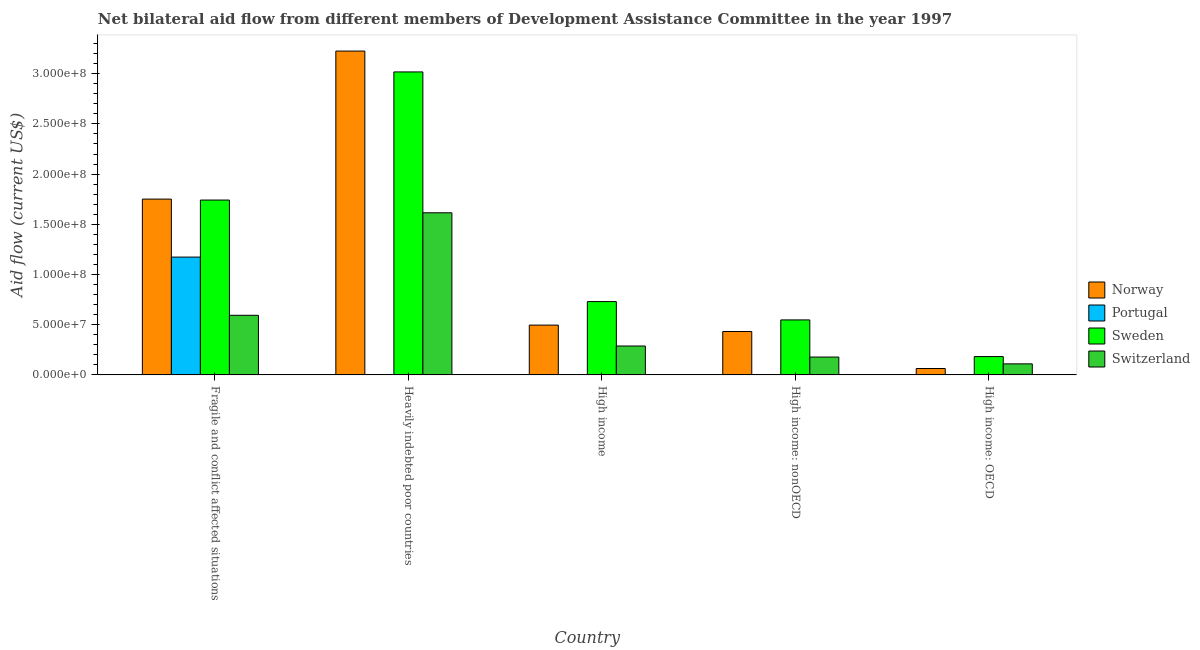How many different coloured bars are there?
Offer a very short reply. 4. Are the number of bars per tick equal to the number of legend labels?
Give a very brief answer. Yes. How many bars are there on the 4th tick from the left?
Offer a very short reply. 4. How many bars are there on the 1st tick from the right?
Your answer should be very brief. 4. What is the label of the 1st group of bars from the left?
Your answer should be compact. Fragile and conflict affected situations. What is the amount of aid given by norway in Heavily indebted poor countries?
Offer a terse response. 3.23e+08. Across all countries, what is the maximum amount of aid given by portugal?
Keep it short and to the point. 1.17e+08. Across all countries, what is the minimum amount of aid given by switzerland?
Provide a succinct answer. 1.10e+07. In which country was the amount of aid given by switzerland maximum?
Your response must be concise. Heavily indebted poor countries. In which country was the amount of aid given by switzerland minimum?
Offer a terse response. High income: OECD. What is the total amount of aid given by switzerland in the graph?
Your response must be concise. 2.78e+08. What is the difference between the amount of aid given by sweden in High income: OECD and that in High income: nonOECD?
Offer a terse response. -3.65e+07. What is the difference between the amount of aid given by sweden in High income and the amount of aid given by switzerland in Fragile and conflict affected situations?
Your answer should be compact. 1.37e+07. What is the average amount of aid given by portugal per country?
Give a very brief answer. 2.36e+07. What is the difference between the amount of aid given by switzerland and amount of aid given by portugal in High income?
Your answer should be very brief. 2.88e+07. What is the ratio of the amount of aid given by switzerland in Fragile and conflict affected situations to that in Heavily indebted poor countries?
Offer a terse response. 0.37. Is the difference between the amount of aid given by portugal in Fragile and conflict affected situations and High income: nonOECD greater than the difference between the amount of aid given by norway in Fragile and conflict affected situations and High income: nonOECD?
Your answer should be very brief. No. What is the difference between the highest and the second highest amount of aid given by norway?
Make the answer very short. 1.47e+08. What is the difference between the highest and the lowest amount of aid given by portugal?
Offer a terse response. 1.17e+08. In how many countries, is the amount of aid given by switzerland greater than the average amount of aid given by switzerland taken over all countries?
Keep it short and to the point. 2. Is the sum of the amount of aid given by norway in Heavily indebted poor countries and High income: OECD greater than the maximum amount of aid given by portugal across all countries?
Provide a succinct answer. Yes. Is it the case that in every country, the sum of the amount of aid given by portugal and amount of aid given by switzerland is greater than the sum of amount of aid given by norway and amount of aid given by sweden?
Make the answer very short. No. What does the 1st bar from the right in Fragile and conflict affected situations represents?
Give a very brief answer. Switzerland. How many bars are there?
Provide a short and direct response. 20. How are the legend labels stacked?
Your response must be concise. Vertical. What is the title of the graph?
Your answer should be very brief. Net bilateral aid flow from different members of Development Assistance Committee in the year 1997. What is the Aid flow (current US$) of Norway in Fragile and conflict affected situations?
Make the answer very short. 1.75e+08. What is the Aid flow (current US$) in Portugal in Fragile and conflict affected situations?
Ensure brevity in your answer.  1.17e+08. What is the Aid flow (current US$) in Sweden in Fragile and conflict affected situations?
Offer a very short reply. 1.74e+08. What is the Aid flow (current US$) of Switzerland in Fragile and conflict affected situations?
Your answer should be very brief. 5.94e+07. What is the Aid flow (current US$) of Norway in Heavily indebted poor countries?
Your response must be concise. 3.23e+08. What is the Aid flow (current US$) of Portugal in Heavily indebted poor countries?
Ensure brevity in your answer.  2.50e+05. What is the Aid flow (current US$) in Sweden in Heavily indebted poor countries?
Your response must be concise. 3.02e+08. What is the Aid flow (current US$) in Switzerland in Heavily indebted poor countries?
Provide a succinct answer. 1.61e+08. What is the Aid flow (current US$) in Norway in High income?
Give a very brief answer. 4.96e+07. What is the Aid flow (current US$) in Portugal in High income?
Provide a succinct answer. 2.00e+04. What is the Aid flow (current US$) of Sweden in High income?
Your response must be concise. 7.30e+07. What is the Aid flow (current US$) of Switzerland in High income?
Offer a very short reply. 2.88e+07. What is the Aid flow (current US$) in Norway in High income: nonOECD?
Your response must be concise. 4.32e+07. What is the Aid flow (current US$) of Portugal in High income: nonOECD?
Offer a terse response. 2.30e+05. What is the Aid flow (current US$) in Sweden in High income: nonOECD?
Provide a succinct answer. 5.48e+07. What is the Aid flow (current US$) of Switzerland in High income: nonOECD?
Your answer should be compact. 1.78e+07. What is the Aid flow (current US$) of Norway in High income: OECD?
Make the answer very short. 6.38e+06. What is the Aid flow (current US$) of Sweden in High income: OECD?
Offer a very short reply. 1.83e+07. What is the Aid flow (current US$) of Switzerland in High income: OECD?
Give a very brief answer. 1.10e+07. Across all countries, what is the maximum Aid flow (current US$) of Norway?
Give a very brief answer. 3.23e+08. Across all countries, what is the maximum Aid flow (current US$) of Portugal?
Keep it short and to the point. 1.17e+08. Across all countries, what is the maximum Aid flow (current US$) of Sweden?
Give a very brief answer. 3.02e+08. Across all countries, what is the maximum Aid flow (current US$) in Switzerland?
Ensure brevity in your answer.  1.61e+08. Across all countries, what is the minimum Aid flow (current US$) in Norway?
Provide a short and direct response. 6.38e+06. Across all countries, what is the minimum Aid flow (current US$) of Sweden?
Your answer should be compact. 1.83e+07. Across all countries, what is the minimum Aid flow (current US$) in Switzerland?
Your answer should be compact. 1.10e+07. What is the total Aid flow (current US$) in Norway in the graph?
Provide a short and direct response. 5.97e+08. What is the total Aid flow (current US$) in Portugal in the graph?
Offer a very short reply. 1.18e+08. What is the total Aid flow (current US$) in Sweden in the graph?
Offer a terse response. 6.22e+08. What is the total Aid flow (current US$) in Switzerland in the graph?
Ensure brevity in your answer.  2.78e+08. What is the difference between the Aid flow (current US$) in Norway in Fragile and conflict affected situations and that in Heavily indebted poor countries?
Your response must be concise. -1.47e+08. What is the difference between the Aid flow (current US$) of Portugal in Fragile and conflict affected situations and that in Heavily indebted poor countries?
Make the answer very short. 1.17e+08. What is the difference between the Aid flow (current US$) of Sweden in Fragile and conflict affected situations and that in Heavily indebted poor countries?
Provide a short and direct response. -1.28e+08. What is the difference between the Aid flow (current US$) in Switzerland in Fragile and conflict affected situations and that in Heavily indebted poor countries?
Ensure brevity in your answer.  -1.02e+08. What is the difference between the Aid flow (current US$) of Norway in Fragile and conflict affected situations and that in High income?
Ensure brevity in your answer.  1.25e+08. What is the difference between the Aid flow (current US$) of Portugal in Fragile and conflict affected situations and that in High income?
Your response must be concise. 1.17e+08. What is the difference between the Aid flow (current US$) of Sweden in Fragile and conflict affected situations and that in High income?
Offer a very short reply. 1.01e+08. What is the difference between the Aid flow (current US$) of Switzerland in Fragile and conflict affected situations and that in High income?
Ensure brevity in your answer.  3.06e+07. What is the difference between the Aid flow (current US$) in Norway in Fragile and conflict affected situations and that in High income: nonOECD?
Give a very brief answer. 1.32e+08. What is the difference between the Aid flow (current US$) of Portugal in Fragile and conflict affected situations and that in High income: nonOECD?
Give a very brief answer. 1.17e+08. What is the difference between the Aid flow (current US$) in Sweden in Fragile and conflict affected situations and that in High income: nonOECD?
Ensure brevity in your answer.  1.19e+08. What is the difference between the Aid flow (current US$) in Switzerland in Fragile and conflict affected situations and that in High income: nonOECD?
Provide a succinct answer. 4.16e+07. What is the difference between the Aid flow (current US$) of Norway in Fragile and conflict affected situations and that in High income: OECD?
Provide a succinct answer. 1.69e+08. What is the difference between the Aid flow (current US$) of Portugal in Fragile and conflict affected situations and that in High income: OECD?
Provide a short and direct response. 1.17e+08. What is the difference between the Aid flow (current US$) of Sweden in Fragile and conflict affected situations and that in High income: OECD?
Provide a short and direct response. 1.56e+08. What is the difference between the Aid flow (current US$) of Switzerland in Fragile and conflict affected situations and that in High income: OECD?
Provide a succinct answer. 4.84e+07. What is the difference between the Aid flow (current US$) of Norway in Heavily indebted poor countries and that in High income?
Make the answer very short. 2.73e+08. What is the difference between the Aid flow (current US$) of Sweden in Heavily indebted poor countries and that in High income?
Give a very brief answer. 2.29e+08. What is the difference between the Aid flow (current US$) in Switzerland in Heavily indebted poor countries and that in High income?
Offer a very short reply. 1.33e+08. What is the difference between the Aid flow (current US$) of Norway in Heavily indebted poor countries and that in High income: nonOECD?
Your response must be concise. 2.79e+08. What is the difference between the Aid flow (current US$) of Portugal in Heavily indebted poor countries and that in High income: nonOECD?
Ensure brevity in your answer.  2.00e+04. What is the difference between the Aid flow (current US$) of Sweden in Heavily indebted poor countries and that in High income: nonOECD?
Your answer should be compact. 2.47e+08. What is the difference between the Aid flow (current US$) of Switzerland in Heavily indebted poor countries and that in High income: nonOECD?
Provide a short and direct response. 1.44e+08. What is the difference between the Aid flow (current US$) of Norway in Heavily indebted poor countries and that in High income: OECD?
Ensure brevity in your answer.  3.16e+08. What is the difference between the Aid flow (current US$) in Portugal in Heavily indebted poor countries and that in High income: OECD?
Provide a short and direct response. -1.60e+05. What is the difference between the Aid flow (current US$) of Sweden in Heavily indebted poor countries and that in High income: OECD?
Your response must be concise. 2.83e+08. What is the difference between the Aid flow (current US$) in Switzerland in Heavily indebted poor countries and that in High income: OECD?
Your response must be concise. 1.50e+08. What is the difference between the Aid flow (current US$) of Norway in High income and that in High income: nonOECD?
Your answer should be compact. 6.38e+06. What is the difference between the Aid flow (current US$) of Portugal in High income and that in High income: nonOECD?
Offer a very short reply. -2.10e+05. What is the difference between the Aid flow (current US$) of Sweden in High income and that in High income: nonOECD?
Offer a very short reply. 1.83e+07. What is the difference between the Aid flow (current US$) in Switzerland in High income and that in High income: nonOECD?
Provide a succinct answer. 1.10e+07. What is the difference between the Aid flow (current US$) of Norway in High income and that in High income: OECD?
Your answer should be very brief. 4.32e+07. What is the difference between the Aid flow (current US$) in Portugal in High income and that in High income: OECD?
Your response must be concise. -3.90e+05. What is the difference between the Aid flow (current US$) in Sweden in High income and that in High income: OECD?
Provide a short and direct response. 5.48e+07. What is the difference between the Aid flow (current US$) of Switzerland in High income and that in High income: OECD?
Make the answer very short. 1.78e+07. What is the difference between the Aid flow (current US$) in Norway in High income: nonOECD and that in High income: OECD?
Provide a short and direct response. 3.68e+07. What is the difference between the Aid flow (current US$) in Sweden in High income: nonOECD and that in High income: OECD?
Offer a very short reply. 3.65e+07. What is the difference between the Aid flow (current US$) in Switzerland in High income: nonOECD and that in High income: OECD?
Offer a terse response. 6.79e+06. What is the difference between the Aid flow (current US$) in Norway in Fragile and conflict affected situations and the Aid flow (current US$) in Portugal in Heavily indebted poor countries?
Ensure brevity in your answer.  1.75e+08. What is the difference between the Aid flow (current US$) in Norway in Fragile and conflict affected situations and the Aid flow (current US$) in Sweden in Heavily indebted poor countries?
Offer a terse response. -1.27e+08. What is the difference between the Aid flow (current US$) of Norway in Fragile and conflict affected situations and the Aid flow (current US$) of Switzerland in Heavily indebted poor countries?
Offer a very short reply. 1.36e+07. What is the difference between the Aid flow (current US$) of Portugal in Fragile and conflict affected situations and the Aid flow (current US$) of Sweden in Heavily indebted poor countries?
Your answer should be very brief. -1.84e+08. What is the difference between the Aid flow (current US$) in Portugal in Fragile and conflict affected situations and the Aid flow (current US$) in Switzerland in Heavily indebted poor countries?
Your response must be concise. -4.41e+07. What is the difference between the Aid flow (current US$) in Sweden in Fragile and conflict affected situations and the Aid flow (current US$) in Switzerland in Heavily indebted poor countries?
Ensure brevity in your answer.  1.27e+07. What is the difference between the Aid flow (current US$) in Norway in Fragile and conflict affected situations and the Aid flow (current US$) in Portugal in High income?
Provide a short and direct response. 1.75e+08. What is the difference between the Aid flow (current US$) of Norway in Fragile and conflict affected situations and the Aid flow (current US$) of Sweden in High income?
Ensure brevity in your answer.  1.02e+08. What is the difference between the Aid flow (current US$) in Norway in Fragile and conflict affected situations and the Aid flow (current US$) in Switzerland in High income?
Offer a very short reply. 1.46e+08. What is the difference between the Aid flow (current US$) of Portugal in Fragile and conflict affected situations and the Aid flow (current US$) of Sweden in High income?
Give a very brief answer. 4.43e+07. What is the difference between the Aid flow (current US$) in Portugal in Fragile and conflict affected situations and the Aid flow (current US$) in Switzerland in High income?
Keep it short and to the point. 8.86e+07. What is the difference between the Aid flow (current US$) of Sweden in Fragile and conflict affected situations and the Aid flow (current US$) of Switzerland in High income?
Your answer should be compact. 1.45e+08. What is the difference between the Aid flow (current US$) in Norway in Fragile and conflict affected situations and the Aid flow (current US$) in Portugal in High income: nonOECD?
Offer a very short reply. 1.75e+08. What is the difference between the Aid flow (current US$) of Norway in Fragile and conflict affected situations and the Aid flow (current US$) of Sweden in High income: nonOECD?
Give a very brief answer. 1.20e+08. What is the difference between the Aid flow (current US$) of Norway in Fragile and conflict affected situations and the Aid flow (current US$) of Switzerland in High income: nonOECD?
Ensure brevity in your answer.  1.57e+08. What is the difference between the Aid flow (current US$) in Portugal in Fragile and conflict affected situations and the Aid flow (current US$) in Sweden in High income: nonOECD?
Make the answer very short. 6.26e+07. What is the difference between the Aid flow (current US$) in Portugal in Fragile and conflict affected situations and the Aid flow (current US$) in Switzerland in High income: nonOECD?
Your response must be concise. 9.96e+07. What is the difference between the Aid flow (current US$) of Sweden in Fragile and conflict affected situations and the Aid flow (current US$) of Switzerland in High income: nonOECD?
Offer a terse response. 1.56e+08. What is the difference between the Aid flow (current US$) in Norway in Fragile and conflict affected situations and the Aid flow (current US$) in Portugal in High income: OECD?
Your answer should be very brief. 1.75e+08. What is the difference between the Aid flow (current US$) in Norway in Fragile and conflict affected situations and the Aid flow (current US$) in Sweden in High income: OECD?
Provide a short and direct response. 1.57e+08. What is the difference between the Aid flow (current US$) of Norway in Fragile and conflict affected situations and the Aid flow (current US$) of Switzerland in High income: OECD?
Make the answer very short. 1.64e+08. What is the difference between the Aid flow (current US$) in Portugal in Fragile and conflict affected situations and the Aid flow (current US$) in Sweden in High income: OECD?
Offer a very short reply. 9.91e+07. What is the difference between the Aid flow (current US$) in Portugal in Fragile and conflict affected situations and the Aid flow (current US$) in Switzerland in High income: OECD?
Your answer should be compact. 1.06e+08. What is the difference between the Aid flow (current US$) in Sweden in Fragile and conflict affected situations and the Aid flow (current US$) in Switzerland in High income: OECD?
Make the answer very short. 1.63e+08. What is the difference between the Aid flow (current US$) in Norway in Heavily indebted poor countries and the Aid flow (current US$) in Portugal in High income?
Offer a terse response. 3.22e+08. What is the difference between the Aid flow (current US$) in Norway in Heavily indebted poor countries and the Aid flow (current US$) in Sweden in High income?
Provide a succinct answer. 2.49e+08. What is the difference between the Aid flow (current US$) in Norway in Heavily indebted poor countries and the Aid flow (current US$) in Switzerland in High income?
Your answer should be very brief. 2.94e+08. What is the difference between the Aid flow (current US$) in Portugal in Heavily indebted poor countries and the Aid flow (current US$) in Sweden in High income?
Offer a terse response. -7.28e+07. What is the difference between the Aid flow (current US$) of Portugal in Heavily indebted poor countries and the Aid flow (current US$) of Switzerland in High income?
Give a very brief answer. -2.85e+07. What is the difference between the Aid flow (current US$) in Sweden in Heavily indebted poor countries and the Aid flow (current US$) in Switzerland in High income?
Your answer should be compact. 2.73e+08. What is the difference between the Aid flow (current US$) of Norway in Heavily indebted poor countries and the Aid flow (current US$) of Portugal in High income: nonOECD?
Ensure brevity in your answer.  3.22e+08. What is the difference between the Aid flow (current US$) of Norway in Heavily indebted poor countries and the Aid flow (current US$) of Sweden in High income: nonOECD?
Provide a short and direct response. 2.68e+08. What is the difference between the Aid flow (current US$) of Norway in Heavily indebted poor countries and the Aid flow (current US$) of Switzerland in High income: nonOECD?
Provide a succinct answer. 3.05e+08. What is the difference between the Aid flow (current US$) in Portugal in Heavily indebted poor countries and the Aid flow (current US$) in Sweden in High income: nonOECD?
Keep it short and to the point. -5.45e+07. What is the difference between the Aid flow (current US$) of Portugal in Heavily indebted poor countries and the Aid flow (current US$) of Switzerland in High income: nonOECD?
Give a very brief answer. -1.75e+07. What is the difference between the Aid flow (current US$) in Sweden in Heavily indebted poor countries and the Aid flow (current US$) in Switzerland in High income: nonOECD?
Provide a succinct answer. 2.84e+08. What is the difference between the Aid flow (current US$) of Norway in Heavily indebted poor countries and the Aid flow (current US$) of Portugal in High income: OECD?
Offer a terse response. 3.22e+08. What is the difference between the Aid flow (current US$) of Norway in Heavily indebted poor countries and the Aid flow (current US$) of Sweden in High income: OECD?
Offer a very short reply. 3.04e+08. What is the difference between the Aid flow (current US$) in Norway in Heavily indebted poor countries and the Aid flow (current US$) in Switzerland in High income: OECD?
Make the answer very short. 3.12e+08. What is the difference between the Aid flow (current US$) in Portugal in Heavily indebted poor countries and the Aid flow (current US$) in Sweden in High income: OECD?
Keep it short and to the point. -1.80e+07. What is the difference between the Aid flow (current US$) in Portugal in Heavily indebted poor countries and the Aid flow (current US$) in Switzerland in High income: OECD?
Offer a very short reply. -1.08e+07. What is the difference between the Aid flow (current US$) of Sweden in Heavily indebted poor countries and the Aid flow (current US$) of Switzerland in High income: OECD?
Provide a short and direct response. 2.91e+08. What is the difference between the Aid flow (current US$) in Norway in High income and the Aid flow (current US$) in Portugal in High income: nonOECD?
Ensure brevity in your answer.  4.94e+07. What is the difference between the Aid flow (current US$) of Norway in High income and the Aid flow (current US$) of Sweden in High income: nonOECD?
Your answer should be compact. -5.17e+06. What is the difference between the Aid flow (current US$) in Norway in High income and the Aid flow (current US$) in Switzerland in High income: nonOECD?
Make the answer very short. 3.18e+07. What is the difference between the Aid flow (current US$) of Portugal in High income and the Aid flow (current US$) of Sweden in High income: nonOECD?
Give a very brief answer. -5.48e+07. What is the difference between the Aid flow (current US$) of Portugal in High income and the Aid flow (current US$) of Switzerland in High income: nonOECD?
Keep it short and to the point. -1.78e+07. What is the difference between the Aid flow (current US$) in Sweden in High income and the Aid flow (current US$) in Switzerland in High income: nonOECD?
Provide a succinct answer. 5.52e+07. What is the difference between the Aid flow (current US$) in Norway in High income and the Aid flow (current US$) in Portugal in High income: OECD?
Offer a very short reply. 4.92e+07. What is the difference between the Aid flow (current US$) of Norway in High income and the Aid flow (current US$) of Sweden in High income: OECD?
Your answer should be compact. 3.13e+07. What is the difference between the Aid flow (current US$) of Norway in High income and the Aid flow (current US$) of Switzerland in High income: OECD?
Your response must be concise. 3.86e+07. What is the difference between the Aid flow (current US$) of Portugal in High income and the Aid flow (current US$) of Sweden in High income: OECD?
Offer a terse response. -1.82e+07. What is the difference between the Aid flow (current US$) of Portugal in High income and the Aid flow (current US$) of Switzerland in High income: OECD?
Make the answer very short. -1.10e+07. What is the difference between the Aid flow (current US$) in Sweden in High income and the Aid flow (current US$) in Switzerland in High income: OECD?
Your response must be concise. 6.20e+07. What is the difference between the Aid flow (current US$) in Norway in High income: nonOECD and the Aid flow (current US$) in Portugal in High income: OECD?
Keep it short and to the point. 4.28e+07. What is the difference between the Aid flow (current US$) of Norway in High income: nonOECD and the Aid flow (current US$) of Sweden in High income: OECD?
Ensure brevity in your answer.  2.50e+07. What is the difference between the Aid flow (current US$) in Norway in High income: nonOECD and the Aid flow (current US$) in Switzerland in High income: OECD?
Make the answer very short. 3.22e+07. What is the difference between the Aid flow (current US$) of Portugal in High income: nonOECD and the Aid flow (current US$) of Sweden in High income: OECD?
Your answer should be very brief. -1.80e+07. What is the difference between the Aid flow (current US$) of Portugal in High income: nonOECD and the Aid flow (current US$) of Switzerland in High income: OECD?
Ensure brevity in your answer.  -1.08e+07. What is the difference between the Aid flow (current US$) of Sweden in High income: nonOECD and the Aid flow (current US$) of Switzerland in High income: OECD?
Make the answer very short. 4.38e+07. What is the average Aid flow (current US$) in Norway per country?
Keep it short and to the point. 1.19e+08. What is the average Aid flow (current US$) of Portugal per country?
Offer a very short reply. 2.36e+07. What is the average Aid flow (current US$) in Sweden per country?
Offer a terse response. 1.24e+08. What is the average Aid flow (current US$) of Switzerland per country?
Your answer should be very brief. 5.57e+07. What is the difference between the Aid flow (current US$) in Norway and Aid flow (current US$) in Portugal in Fragile and conflict affected situations?
Your answer should be compact. 5.77e+07. What is the difference between the Aid flow (current US$) of Norway and Aid flow (current US$) of Sweden in Fragile and conflict affected situations?
Keep it short and to the point. 9.40e+05. What is the difference between the Aid flow (current US$) in Norway and Aid flow (current US$) in Switzerland in Fragile and conflict affected situations?
Keep it short and to the point. 1.16e+08. What is the difference between the Aid flow (current US$) of Portugal and Aid flow (current US$) of Sweden in Fragile and conflict affected situations?
Ensure brevity in your answer.  -5.68e+07. What is the difference between the Aid flow (current US$) in Portugal and Aid flow (current US$) in Switzerland in Fragile and conflict affected situations?
Your answer should be compact. 5.80e+07. What is the difference between the Aid flow (current US$) of Sweden and Aid flow (current US$) of Switzerland in Fragile and conflict affected situations?
Your answer should be very brief. 1.15e+08. What is the difference between the Aid flow (current US$) of Norway and Aid flow (current US$) of Portugal in Heavily indebted poor countries?
Your answer should be very brief. 3.22e+08. What is the difference between the Aid flow (current US$) in Norway and Aid flow (current US$) in Sweden in Heavily indebted poor countries?
Your response must be concise. 2.08e+07. What is the difference between the Aid flow (current US$) of Norway and Aid flow (current US$) of Switzerland in Heavily indebted poor countries?
Give a very brief answer. 1.61e+08. What is the difference between the Aid flow (current US$) in Portugal and Aid flow (current US$) in Sweden in Heavily indebted poor countries?
Your response must be concise. -3.01e+08. What is the difference between the Aid flow (current US$) of Portugal and Aid flow (current US$) of Switzerland in Heavily indebted poor countries?
Your answer should be compact. -1.61e+08. What is the difference between the Aid flow (current US$) of Sweden and Aid flow (current US$) of Switzerland in Heavily indebted poor countries?
Your answer should be very brief. 1.40e+08. What is the difference between the Aid flow (current US$) in Norway and Aid flow (current US$) in Portugal in High income?
Offer a terse response. 4.96e+07. What is the difference between the Aid flow (current US$) in Norway and Aid flow (current US$) in Sweden in High income?
Provide a succinct answer. -2.34e+07. What is the difference between the Aid flow (current US$) of Norway and Aid flow (current US$) of Switzerland in High income?
Your response must be concise. 2.08e+07. What is the difference between the Aid flow (current US$) of Portugal and Aid flow (current US$) of Sweden in High income?
Your response must be concise. -7.30e+07. What is the difference between the Aid flow (current US$) of Portugal and Aid flow (current US$) of Switzerland in High income?
Give a very brief answer. -2.88e+07. What is the difference between the Aid flow (current US$) of Sweden and Aid flow (current US$) of Switzerland in High income?
Your answer should be very brief. 4.42e+07. What is the difference between the Aid flow (current US$) of Norway and Aid flow (current US$) of Portugal in High income: nonOECD?
Offer a terse response. 4.30e+07. What is the difference between the Aid flow (current US$) of Norway and Aid flow (current US$) of Sweden in High income: nonOECD?
Make the answer very short. -1.16e+07. What is the difference between the Aid flow (current US$) of Norway and Aid flow (current US$) of Switzerland in High income: nonOECD?
Offer a terse response. 2.54e+07. What is the difference between the Aid flow (current US$) in Portugal and Aid flow (current US$) in Sweden in High income: nonOECD?
Provide a succinct answer. -5.45e+07. What is the difference between the Aid flow (current US$) in Portugal and Aid flow (current US$) in Switzerland in High income: nonOECD?
Ensure brevity in your answer.  -1.76e+07. What is the difference between the Aid flow (current US$) in Sweden and Aid flow (current US$) in Switzerland in High income: nonOECD?
Provide a succinct answer. 3.70e+07. What is the difference between the Aid flow (current US$) of Norway and Aid flow (current US$) of Portugal in High income: OECD?
Your response must be concise. 5.97e+06. What is the difference between the Aid flow (current US$) of Norway and Aid flow (current US$) of Sweden in High income: OECD?
Make the answer very short. -1.19e+07. What is the difference between the Aid flow (current US$) in Norway and Aid flow (current US$) in Switzerland in High income: OECD?
Your answer should be compact. -4.62e+06. What is the difference between the Aid flow (current US$) of Portugal and Aid flow (current US$) of Sweden in High income: OECD?
Offer a terse response. -1.78e+07. What is the difference between the Aid flow (current US$) in Portugal and Aid flow (current US$) in Switzerland in High income: OECD?
Your response must be concise. -1.06e+07. What is the difference between the Aid flow (current US$) in Sweden and Aid flow (current US$) in Switzerland in High income: OECD?
Keep it short and to the point. 7.26e+06. What is the ratio of the Aid flow (current US$) in Norway in Fragile and conflict affected situations to that in Heavily indebted poor countries?
Provide a short and direct response. 0.54. What is the ratio of the Aid flow (current US$) of Portugal in Fragile and conflict affected situations to that in Heavily indebted poor countries?
Your answer should be very brief. 469.36. What is the ratio of the Aid flow (current US$) of Sweden in Fragile and conflict affected situations to that in Heavily indebted poor countries?
Provide a succinct answer. 0.58. What is the ratio of the Aid flow (current US$) in Switzerland in Fragile and conflict affected situations to that in Heavily indebted poor countries?
Your response must be concise. 0.37. What is the ratio of the Aid flow (current US$) of Norway in Fragile and conflict affected situations to that in High income?
Your response must be concise. 3.53. What is the ratio of the Aid flow (current US$) of Portugal in Fragile and conflict affected situations to that in High income?
Offer a terse response. 5867. What is the ratio of the Aid flow (current US$) of Sweden in Fragile and conflict affected situations to that in High income?
Provide a short and direct response. 2.38. What is the ratio of the Aid flow (current US$) of Switzerland in Fragile and conflict affected situations to that in High income?
Give a very brief answer. 2.06. What is the ratio of the Aid flow (current US$) of Norway in Fragile and conflict affected situations to that in High income: nonOECD?
Your response must be concise. 4.05. What is the ratio of the Aid flow (current US$) of Portugal in Fragile and conflict affected situations to that in High income: nonOECD?
Your answer should be very brief. 510.17. What is the ratio of the Aid flow (current US$) in Sweden in Fragile and conflict affected situations to that in High income: nonOECD?
Offer a very short reply. 3.18. What is the ratio of the Aid flow (current US$) in Switzerland in Fragile and conflict affected situations to that in High income: nonOECD?
Provide a short and direct response. 3.34. What is the ratio of the Aid flow (current US$) of Norway in Fragile and conflict affected situations to that in High income: OECD?
Make the answer very short. 27.44. What is the ratio of the Aid flow (current US$) in Portugal in Fragile and conflict affected situations to that in High income: OECD?
Ensure brevity in your answer.  286.2. What is the ratio of the Aid flow (current US$) of Sweden in Fragile and conflict affected situations to that in High income: OECD?
Keep it short and to the point. 9.54. What is the ratio of the Aid flow (current US$) of Switzerland in Fragile and conflict affected situations to that in High income: OECD?
Your answer should be compact. 5.4. What is the ratio of the Aid flow (current US$) of Norway in Heavily indebted poor countries to that in High income?
Your answer should be very brief. 6.5. What is the ratio of the Aid flow (current US$) of Sweden in Heavily indebted poor countries to that in High income?
Your answer should be very brief. 4.13. What is the ratio of the Aid flow (current US$) of Switzerland in Heavily indebted poor countries to that in High income?
Offer a terse response. 5.61. What is the ratio of the Aid flow (current US$) of Norway in Heavily indebted poor countries to that in High income: nonOECD?
Make the answer very short. 7.46. What is the ratio of the Aid flow (current US$) of Portugal in Heavily indebted poor countries to that in High income: nonOECD?
Your answer should be compact. 1.09. What is the ratio of the Aid flow (current US$) in Sweden in Heavily indebted poor countries to that in High income: nonOECD?
Provide a succinct answer. 5.51. What is the ratio of the Aid flow (current US$) in Switzerland in Heavily indebted poor countries to that in High income: nonOECD?
Your response must be concise. 9.08. What is the ratio of the Aid flow (current US$) in Norway in Heavily indebted poor countries to that in High income: OECD?
Provide a short and direct response. 50.55. What is the ratio of the Aid flow (current US$) of Portugal in Heavily indebted poor countries to that in High income: OECD?
Make the answer very short. 0.61. What is the ratio of the Aid flow (current US$) of Sweden in Heavily indebted poor countries to that in High income: OECD?
Keep it short and to the point. 16.52. What is the ratio of the Aid flow (current US$) in Switzerland in Heavily indebted poor countries to that in High income: OECD?
Your answer should be compact. 14.68. What is the ratio of the Aid flow (current US$) in Norway in High income to that in High income: nonOECD?
Your answer should be compact. 1.15. What is the ratio of the Aid flow (current US$) in Portugal in High income to that in High income: nonOECD?
Offer a very short reply. 0.09. What is the ratio of the Aid flow (current US$) of Sweden in High income to that in High income: nonOECD?
Offer a terse response. 1.33. What is the ratio of the Aid flow (current US$) of Switzerland in High income to that in High income: nonOECD?
Ensure brevity in your answer.  1.62. What is the ratio of the Aid flow (current US$) of Norway in High income to that in High income: OECD?
Provide a short and direct response. 7.77. What is the ratio of the Aid flow (current US$) of Portugal in High income to that in High income: OECD?
Provide a short and direct response. 0.05. What is the ratio of the Aid flow (current US$) in Sweden in High income to that in High income: OECD?
Ensure brevity in your answer.  4. What is the ratio of the Aid flow (current US$) of Switzerland in High income to that in High income: OECD?
Make the answer very short. 2.62. What is the ratio of the Aid flow (current US$) of Norway in High income: nonOECD to that in High income: OECD?
Your response must be concise. 6.77. What is the ratio of the Aid flow (current US$) in Portugal in High income: nonOECD to that in High income: OECD?
Provide a short and direct response. 0.56. What is the ratio of the Aid flow (current US$) in Sweden in High income: nonOECD to that in High income: OECD?
Give a very brief answer. 3. What is the ratio of the Aid flow (current US$) in Switzerland in High income: nonOECD to that in High income: OECD?
Make the answer very short. 1.62. What is the difference between the highest and the second highest Aid flow (current US$) in Norway?
Your answer should be very brief. 1.47e+08. What is the difference between the highest and the second highest Aid flow (current US$) of Portugal?
Offer a terse response. 1.17e+08. What is the difference between the highest and the second highest Aid flow (current US$) of Sweden?
Your answer should be very brief. 1.28e+08. What is the difference between the highest and the second highest Aid flow (current US$) of Switzerland?
Your answer should be very brief. 1.02e+08. What is the difference between the highest and the lowest Aid flow (current US$) of Norway?
Offer a very short reply. 3.16e+08. What is the difference between the highest and the lowest Aid flow (current US$) of Portugal?
Offer a terse response. 1.17e+08. What is the difference between the highest and the lowest Aid flow (current US$) of Sweden?
Your answer should be very brief. 2.83e+08. What is the difference between the highest and the lowest Aid flow (current US$) in Switzerland?
Give a very brief answer. 1.50e+08. 